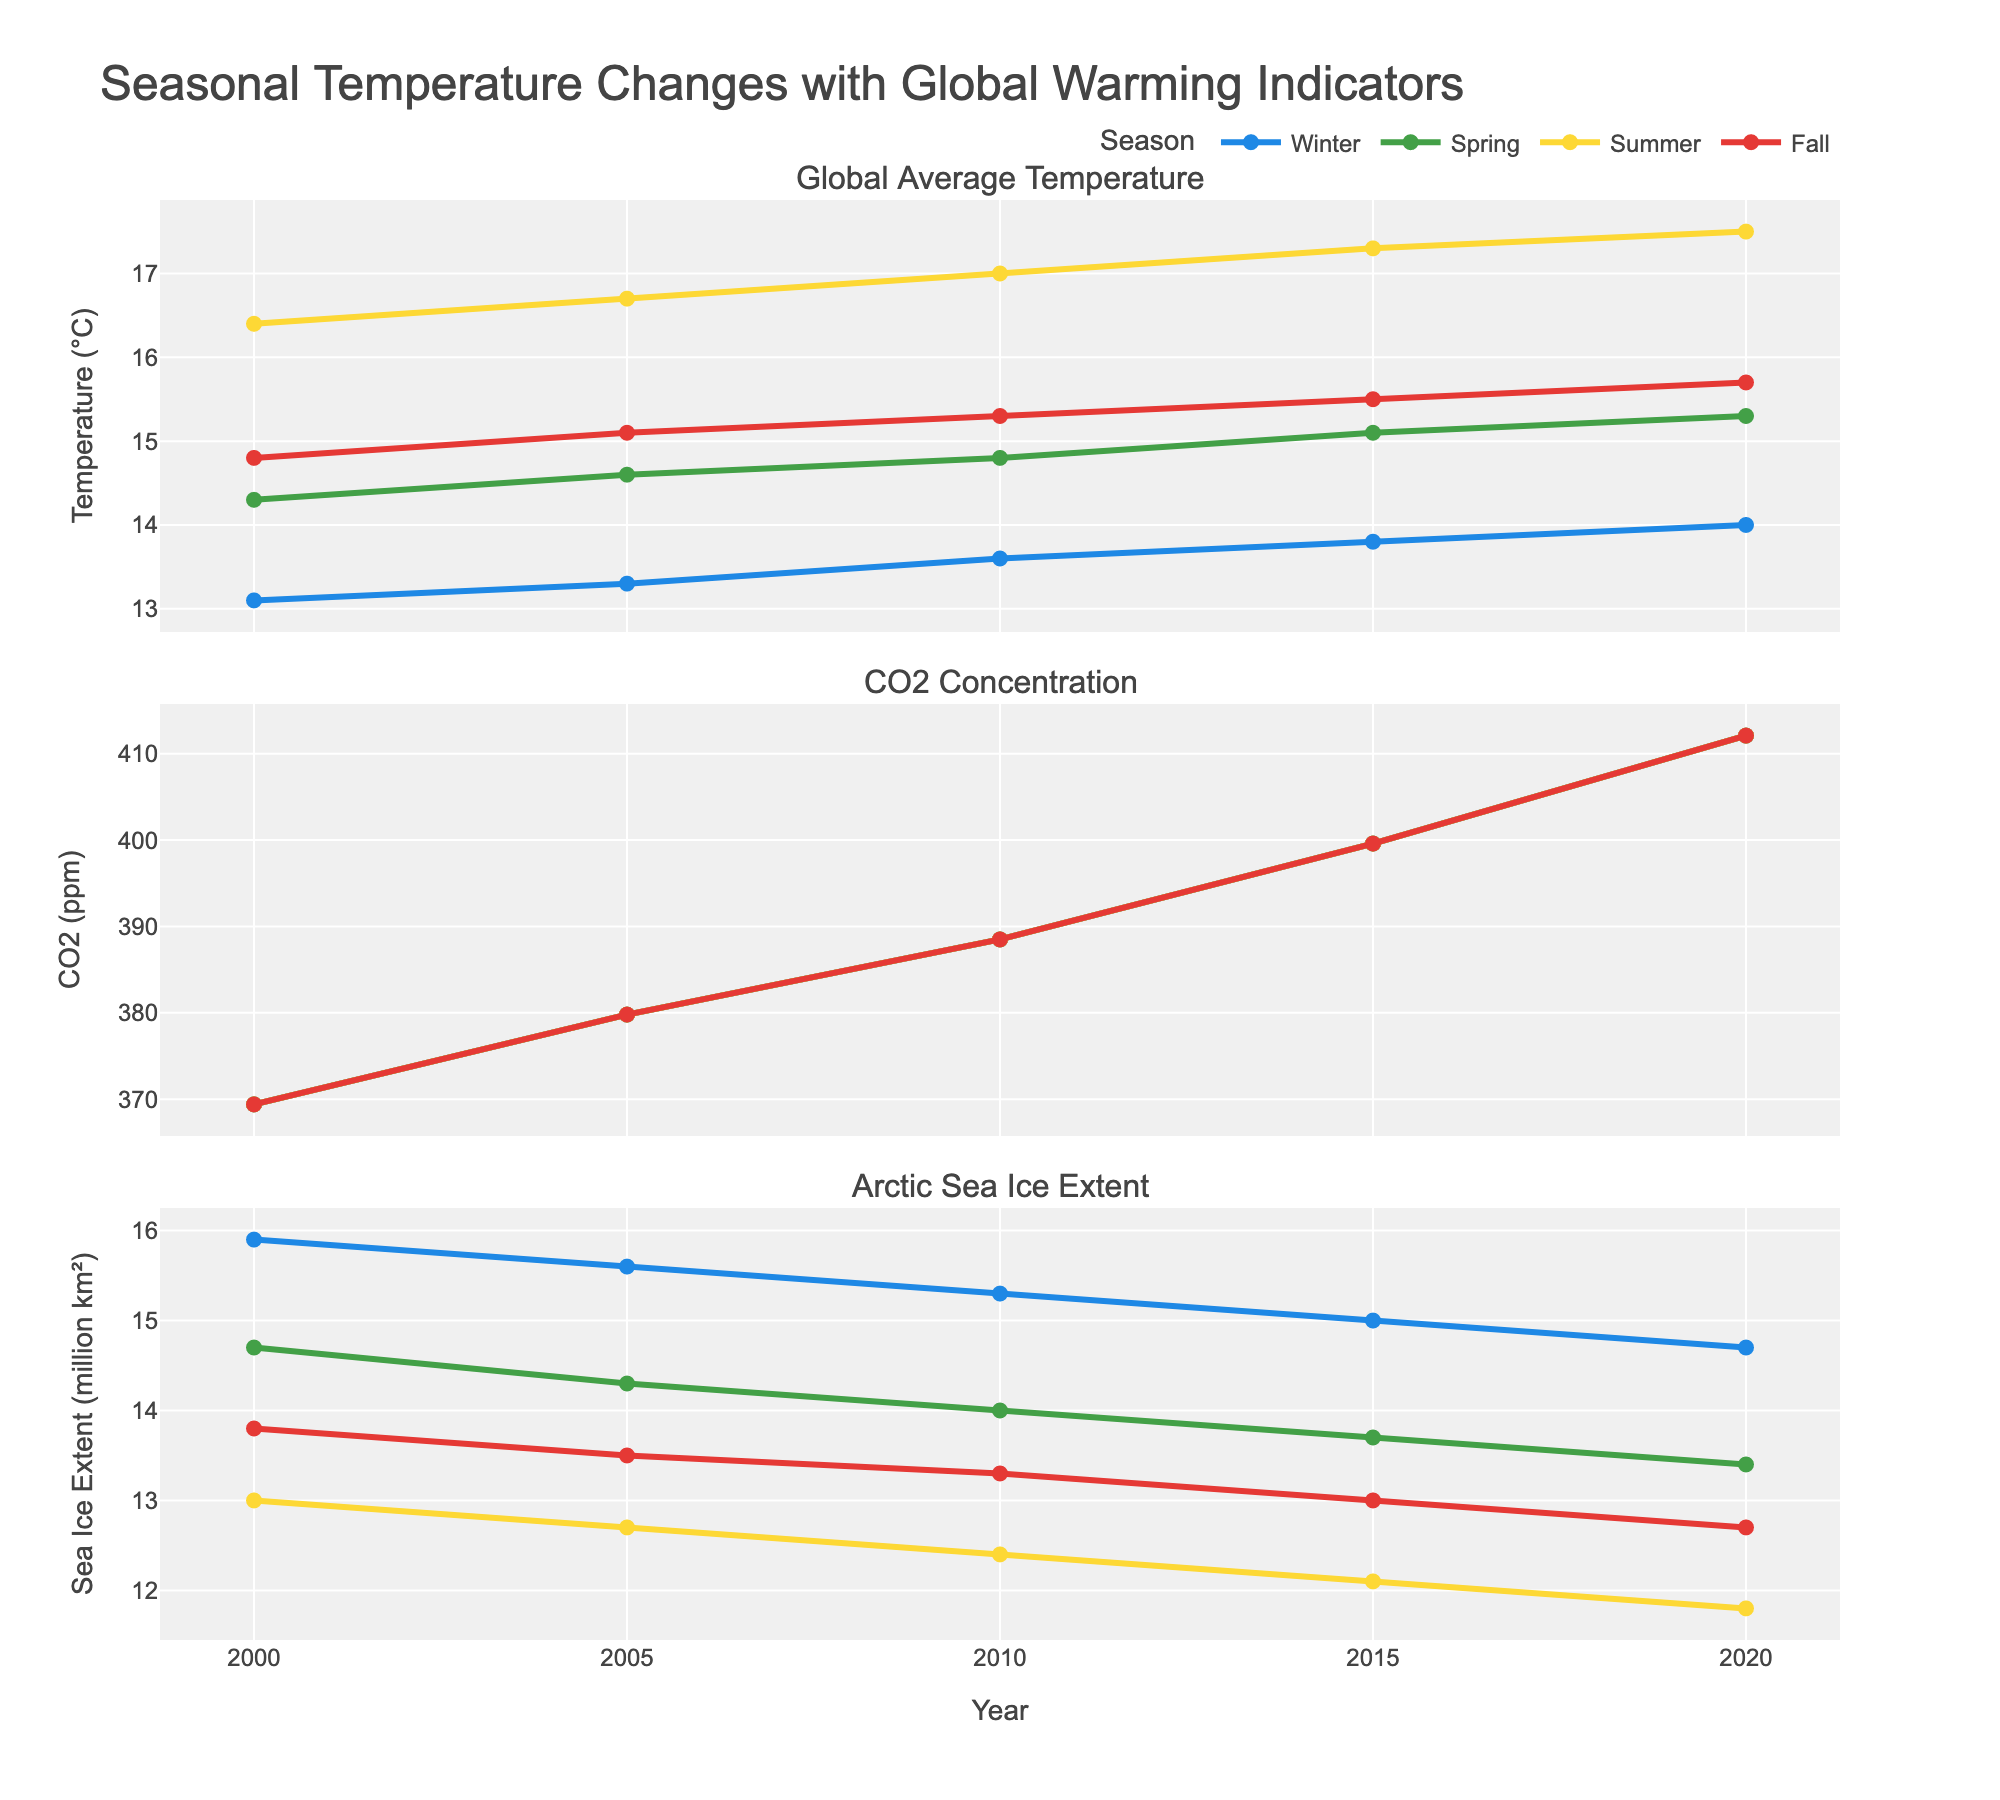what is the trend in global average temperature for winter from 2000 to 2020? Observe the line for winter in the global average temperature subplot (first row). Notice how the temperature values increase from around 13.1°C in 2000 to 14.0°C in 2020, showing an upward trend.
Answer: Upward trend How does the CO2 concentration change from 2000 to 2020? Examine the CO2 concentration subplot (second row). Notice that the CO2 concentration steadily increases from 369.4 ppm in 2000 to 412.1 ppm in 2020.
Answer: Increases Which season shows the highest Arctic sea ice extent in 2020? Look at the Arctic sea ice extent subplot (third row) and find the data points for 2020. The winter season shows the highest extent with 14.7 million km².
Answer: Winter Compare the summer global average temperatures between 2000, 2005, and 2010. Compare the summer data points in the global average temperature subplot (first row). The temperatures are 16.4°C in 2000, 16.7°C in 2005, and 17.0°C in 2010. The temperatures show an increasing trend.
Answer: Increasing trend What is the difference in CO2 concentration between winter in 2000 and winter in 2020? Find the CO2 concentration values for winter in 2000 (369.4 ppm) and 2020 (412.1 ppm). Subtract the 2000 value from the 2020 value: 412.1 - 369.4 = 42.7 ppm.
Answer: 42.7 ppm What is the average Arctic sea ice extent for all seasons in 2015? Find the Arctic sea ice extent values for 2015: 15.0, 13.7, 12.1, and 13.0 million km². Sum these values and divide by 4: (15.0 + 13.7 + 12.1 + 13.0) / 4 = 13.45 million km².
Answer: 13.45 million km² Which season experienced the greatest increase in global average temperature from 2000 to 2020? Compare the temperature values between 2000 and 2020 for each season in the global average temperature subplot (first row):
Winter: 14.0 - 13.1 = 0.9
Spring: 15.3 - 14.3 = 1.0
Summer: 17.5 - 16.4 = 1.1
Fall: 15.7 - 14.8 = 0.9
The summer season experienced the greatest increase with 1.1°C.
Answer: Summer Did the Arctic sea ice extent in fall decrease from 2000 to 2020? Look at the fall data points in the Arctic sea ice extent subplot (third row). Compare the extent in 2000 (13.8 million km²) and 2020 (12.7 million km²). The extent decreased.
Answer: Yes, it decreased How do spring temperatures in 2010 compare to those in 2005? Compare the global average temperature values for spring in 2010 (14.8°C) and 2005 (14.6°C) from the first subplot. The temperature increased by 0.2°C.
Answer: Increased by 0.2°C 